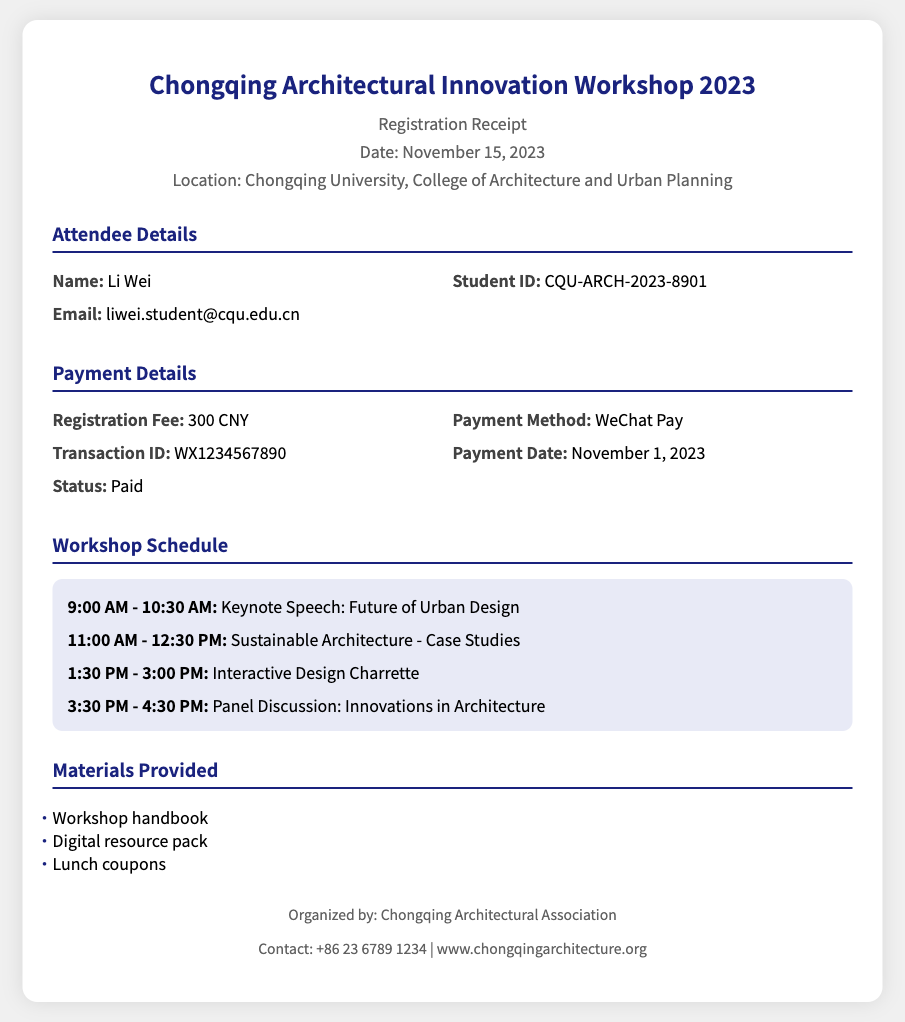What is the name of the event? The name of the event is prominently displayed in the header section of the document.
Answer: Chongqing Architectural Innovation Workshop 2023 What is the date of the event? The date of the event can be found in the header section along with the event name.
Answer: November 15, 2023 What is the registration fee? The registration fee is specified under the Payment Details section of the document.
Answer: 300 CNY What payment method was used? The document states the payment method in the Payment Details section.
Answer: WeChat Pay What is the transaction ID? The transaction ID is included in the Payment Details section of the document for confirmation.
Answer: WX1234567890 What time does the keynote speech start? The start time of the keynote speech is noted in the Workshop Schedule section.
Answer: 9:00 AM Who organized the workshop? The organization responsible for the workshop is mentioned in the footer of the document.
Answer: Chongqing Architectural Association What materials are provided? The materials provided are listed under the Materials Provided section.
Answer: Workshop handbook, Digital resource pack, Lunch coupons What is the email of the attendee? The email of the attendee is provided in the Attendee Details section of the document.
Answer: liwei.student@cqu.edu.cn 